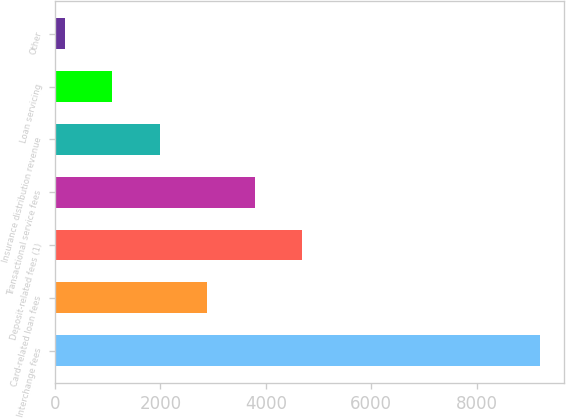Convert chart to OTSL. <chart><loc_0><loc_0><loc_500><loc_500><bar_chart><fcel>Interchange fees<fcel>Card-related loan fees<fcel>Deposit-related fees (1)<fcel>Transactional service fees<fcel>Insurance distribution revenue<fcel>Loan servicing<fcel>Other<nl><fcel>9200<fcel>2887.4<fcel>4691<fcel>3789.2<fcel>1985.6<fcel>1083.8<fcel>182<nl></chart> 